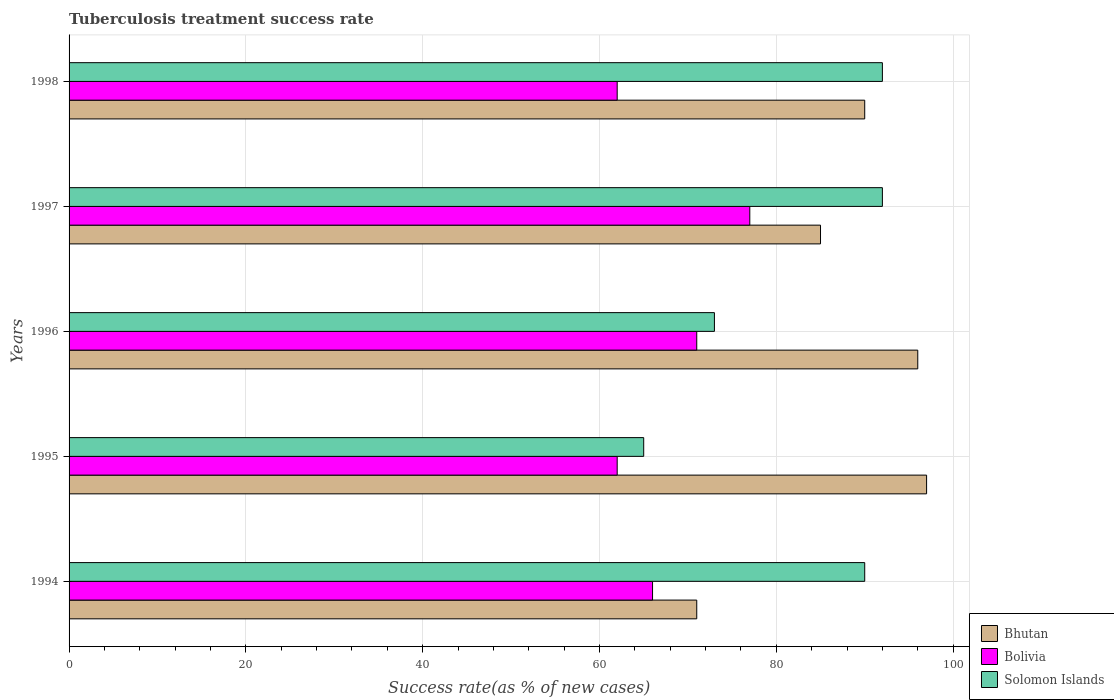How many different coloured bars are there?
Your response must be concise. 3. Are the number of bars per tick equal to the number of legend labels?
Ensure brevity in your answer.  Yes. How many bars are there on the 3rd tick from the top?
Make the answer very short. 3. What is the label of the 1st group of bars from the top?
Keep it short and to the point. 1998. In how many cases, is the number of bars for a given year not equal to the number of legend labels?
Your response must be concise. 0. What is the tuberculosis treatment success rate in Bolivia in 1995?
Your answer should be compact. 62. Across all years, what is the maximum tuberculosis treatment success rate in Bolivia?
Offer a terse response. 77. Across all years, what is the minimum tuberculosis treatment success rate in Bolivia?
Offer a very short reply. 62. In which year was the tuberculosis treatment success rate in Bolivia maximum?
Your answer should be compact. 1997. What is the total tuberculosis treatment success rate in Bolivia in the graph?
Give a very brief answer. 338. What is the difference between the tuberculosis treatment success rate in Bolivia in 1995 and that in 1998?
Your answer should be very brief. 0. What is the average tuberculosis treatment success rate in Bhutan per year?
Offer a very short reply. 87.8. What is the ratio of the tuberculosis treatment success rate in Solomon Islands in 1994 to that in 1996?
Offer a very short reply. 1.23. What is the difference between the highest and the second highest tuberculosis treatment success rate in Solomon Islands?
Provide a short and direct response. 0. What is the difference between the highest and the lowest tuberculosis treatment success rate in Bolivia?
Ensure brevity in your answer.  15. Is the sum of the tuberculosis treatment success rate in Solomon Islands in 1994 and 1998 greater than the maximum tuberculosis treatment success rate in Bolivia across all years?
Offer a very short reply. Yes. What does the 3rd bar from the top in 1997 represents?
Your answer should be very brief. Bhutan. What does the 2nd bar from the bottom in 1995 represents?
Offer a terse response. Bolivia. How many bars are there?
Give a very brief answer. 15. How many years are there in the graph?
Your response must be concise. 5. What is the difference between two consecutive major ticks on the X-axis?
Your answer should be compact. 20. Are the values on the major ticks of X-axis written in scientific E-notation?
Give a very brief answer. No. How many legend labels are there?
Give a very brief answer. 3. What is the title of the graph?
Offer a terse response. Tuberculosis treatment success rate. What is the label or title of the X-axis?
Keep it short and to the point. Success rate(as % of new cases). What is the label or title of the Y-axis?
Provide a short and direct response. Years. What is the Success rate(as % of new cases) of Bhutan in 1994?
Ensure brevity in your answer.  71. What is the Success rate(as % of new cases) in Bhutan in 1995?
Make the answer very short. 97. What is the Success rate(as % of new cases) of Bolivia in 1995?
Provide a succinct answer. 62. What is the Success rate(as % of new cases) in Bhutan in 1996?
Provide a succinct answer. 96. What is the Success rate(as % of new cases) of Bhutan in 1997?
Offer a terse response. 85. What is the Success rate(as % of new cases) in Solomon Islands in 1997?
Provide a short and direct response. 92. What is the Success rate(as % of new cases) in Bhutan in 1998?
Keep it short and to the point. 90. What is the Success rate(as % of new cases) in Solomon Islands in 1998?
Your answer should be compact. 92. Across all years, what is the maximum Success rate(as % of new cases) of Bhutan?
Your answer should be compact. 97. Across all years, what is the maximum Success rate(as % of new cases) in Solomon Islands?
Give a very brief answer. 92. Across all years, what is the minimum Success rate(as % of new cases) in Bhutan?
Your response must be concise. 71. Across all years, what is the minimum Success rate(as % of new cases) in Bolivia?
Your answer should be compact. 62. Across all years, what is the minimum Success rate(as % of new cases) of Solomon Islands?
Offer a very short reply. 65. What is the total Success rate(as % of new cases) in Bhutan in the graph?
Provide a short and direct response. 439. What is the total Success rate(as % of new cases) in Bolivia in the graph?
Keep it short and to the point. 338. What is the total Success rate(as % of new cases) of Solomon Islands in the graph?
Give a very brief answer. 412. What is the difference between the Success rate(as % of new cases) in Bolivia in 1994 and that in 1996?
Ensure brevity in your answer.  -5. What is the difference between the Success rate(as % of new cases) of Bhutan in 1994 and that in 1997?
Keep it short and to the point. -14. What is the difference between the Success rate(as % of new cases) of Solomon Islands in 1994 and that in 1998?
Ensure brevity in your answer.  -2. What is the difference between the Success rate(as % of new cases) in Solomon Islands in 1995 and that in 1996?
Make the answer very short. -8. What is the difference between the Success rate(as % of new cases) of Bolivia in 1995 and that in 1998?
Offer a terse response. 0. What is the difference between the Success rate(as % of new cases) of Solomon Islands in 1995 and that in 1998?
Your response must be concise. -27. What is the difference between the Success rate(as % of new cases) in Solomon Islands in 1996 and that in 1997?
Give a very brief answer. -19. What is the difference between the Success rate(as % of new cases) in Bolivia in 1996 and that in 1998?
Offer a very short reply. 9. What is the difference between the Success rate(as % of new cases) in Solomon Islands in 1996 and that in 1998?
Offer a very short reply. -19. What is the difference between the Success rate(as % of new cases) of Bhutan in 1994 and the Success rate(as % of new cases) of Bolivia in 1995?
Your response must be concise. 9. What is the difference between the Success rate(as % of new cases) of Bhutan in 1994 and the Success rate(as % of new cases) of Solomon Islands in 1995?
Keep it short and to the point. 6. What is the difference between the Success rate(as % of new cases) of Bhutan in 1994 and the Success rate(as % of new cases) of Bolivia in 1997?
Give a very brief answer. -6. What is the difference between the Success rate(as % of new cases) of Bhutan in 1994 and the Success rate(as % of new cases) of Solomon Islands in 1997?
Give a very brief answer. -21. What is the difference between the Success rate(as % of new cases) of Bolivia in 1994 and the Success rate(as % of new cases) of Solomon Islands in 1997?
Ensure brevity in your answer.  -26. What is the difference between the Success rate(as % of new cases) of Bhutan in 1994 and the Success rate(as % of new cases) of Solomon Islands in 1998?
Make the answer very short. -21. What is the difference between the Success rate(as % of new cases) of Bolivia in 1994 and the Success rate(as % of new cases) of Solomon Islands in 1998?
Provide a succinct answer. -26. What is the difference between the Success rate(as % of new cases) of Bhutan in 1995 and the Success rate(as % of new cases) of Bolivia in 1997?
Your answer should be compact. 20. What is the difference between the Success rate(as % of new cases) in Bhutan in 1995 and the Success rate(as % of new cases) in Solomon Islands in 1997?
Offer a terse response. 5. What is the difference between the Success rate(as % of new cases) of Bolivia in 1995 and the Success rate(as % of new cases) of Solomon Islands in 1998?
Offer a very short reply. -30. What is the difference between the Success rate(as % of new cases) of Bhutan in 1996 and the Success rate(as % of new cases) of Bolivia in 1998?
Ensure brevity in your answer.  34. What is the difference between the Success rate(as % of new cases) of Bolivia in 1996 and the Success rate(as % of new cases) of Solomon Islands in 1998?
Offer a terse response. -21. What is the difference between the Success rate(as % of new cases) in Bhutan in 1997 and the Success rate(as % of new cases) in Bolivia in 1998?
Your answer should be compact. 23. What is the difference between the Success rate(as % of new cases) of Bhutan in 1997 and the Success rate(as % of new cases) of Solomon Islands in 1998?
Give a very brief answer. -7. What is the average Success rate(as % of new cases) in Bhutan per year?
Provide a short and direct response. 87.8. What is the average Success rate(as % of new cases) of Bolivia per year?
Your answer should be very brief. 67.6. What is the average Success rate(as % of new cases) of Solomon Islands per year?
Provide a short and direct response. 82.4. In the year 1994, what is the difference between the Success rate(as % of new cases) of Bhutan and Success rate(as % of new cases) of Bolivia?
Your answer should be very brief. 5. In the year 1994, what is the difference between the Success rate(as % of new cases) of Bolivia and Success rate(as % of new cases) of Solomon Islands?
Offer a terse response. -24. In the year 1995, what is the difference between the Success rate(as % of new cases) in Bhutan and Success rate(as % of new cases) in Solomon Islands?
Keep it short and to the point. 32. In the year 1995, what is the difference between the Success rate(as % of new cases) in Bolivia and Success rate(as % of new cases) in Solomon Islands?
Provide a short and direct response. -3. In the year 1996, what is the difference between the Success rate(as % of new cases) in Bhutan and Success rate(as % of new cases) in Solomon Islands?
Offer a very short reply. 23. In the year 1996, what is the difference between the Success rate(as % of new cases) in Bolivia and Success rate(as % of new cases) in Solomon Islands?
Keep it short and to the point. -2. In the year 1997, what is the difference between the Success rate(as % of new cases) of Bolivia and Success rate(as % of new cases) of Solomon Islands?
Offer a terse response. -15. In the year 1998, what is the difference between the Success rate(as % of new cases) of Bhutan and Success rate(as % of new cases) of Solomon Islands?
Your answer should be very brief. -2. In the year 1998, what is the difference between the Success rate(as % of new cases) in Bolivia and Success rate(as % of new cases) in Solomon Islands?
Your answer should be compact. -30. What is the ratio of the Success rate(as % of new cases) of Bhutan in 1994 to that in 1995?
Offer a terse response. 0.73. What is the ratio of the Success rate(as % of new cases) in Bolivia in 1994 to that in 1995?
Your response must be concise. 1.06. What is the ratio of the Success rate(as % of new cases) of Solomon Islands in 1994 to that in 1995?
Your response must be concise. 1.38. What is the ratio of the Success rate(as % of new cases) of Bhutan in 1994 to that in 1996?
Offer a very short reply. 0.74. What is the ratio of the Success rate(as % of new cases) in Bolivia in 1994 to that in 1996?
Give a very brief answer. 0.93. What is the ratio of the Success rate(as % of new cases) of Solomon Islands in 1994 to that in 1996?
Ensure brevity in your answer.  1.23. What is the ratio of the Success rate(as % of new cases) in Bhutan in 1994 to that in 1997?
Your response must be concise. 0.84. What is the ratio of the Success rate(as % of new cases) in Bolivia in 1994 to that in 1997?
Ensure brevity in your answer.  0.86. What is the ratio of the Success rate(as % of new cases) of Solomon Islands in 1994 to that in 1997?
Ensure brevity in your answer.  0.98. What is the ratio of the Success rate(as % of new cases) in Bhutan in 1994 to that in 1998?
Provide a short and direct response. 0.79. What is the ratio of the Success rate(as % of new cases) in Bolivia in 1994 to that in 1998?
Offer a very short reply. 1.06. What is the ratio of the Success rate(as % of new cases) in Solomon Islands in 1994 to that in 1998?
Keep it short and to the point. 0.98. What is the ratio of the Success rate(as % of new cases) of Bhutan in 1995 to that in 1996?
Give a very brief answer. 1.01. What is the ratio of the Success rate(as % of new cases) of Bolivia in 1995 to that in 1996?
Offer a very short reply. 0.87. What is the ratio of the Success rate(as % of new cases) of Solomon Islands in 1995 to that in 1996?
Keep it short and to the point. 0.89. What is the ratio of the Success rate(as % of new cases) of Bhutan in 1995 to that in 1997?
Offer a very short reply. 1.14. What is the ratio of the Success rate(as % of new cases) in Bolivia in 1995 to that in 1997?
Your answer should be compact. 0.81. What is the ratio of the Success rate(as % of new cases) of Solomon Islands in 1995 to that in 1997?
Make the answer very short. 0.71. What is the ratio of the Success rate(as % of new cases) of Bhutan in 1995 to that in 1998?
Offer a very short reply. 1.08. What is the ratio of the Success rate(as % of new cases) of Solomon Islands in 1995 to that in 1998?
Ensure brevity in your answer.  0.71. What is the ratio of the Success rate(as % of new cases) in Bhutan in 1996 to that in 1997?
Give a very brief answer. 1.13. What is the ratio of the Success rate(as % of new cases) in Bolivia in 1996 to that in 1997?
Ensure brevity in your answer.  0.92. What is the ratio of the Success rate(as % of new cases) of Solomon Islands in 1996 to that in 1997?
Make the answer very short. 0.79. What is the ratio of the Success rate(as % of new cases) of Bhutan in 1996 to that in 1998?
Your response must be concise. 1.07. What is the ratio of the Success rate(as % of new cases) of Bolivia in 1996 to that in 1998?
Your answer should be compact. 1.15. What is the ratio of the Success rate(as % of new cases) in Solomon Islands in 1996 to that in 1998?
Offer a terse response. 0.79. What is the ratio of the Success rate(as % of new cases) of Bolivia in 1997 to that in 1998?
Provide a succinct answer. 1.24. What is the difference between the highest and the second highest Success rate(as % of new cases) in Bolivia?
Ensure brevity in your answer.  6. What is the difference between the highest and the second highest Success rate(as % of new cases) in Solomon Islands?
Keep it short and to the point. 0. What is the difference between the highest and the lowest Success rate(as % of new cases) of Bhutan?
Provide a succinct answer. 26. 